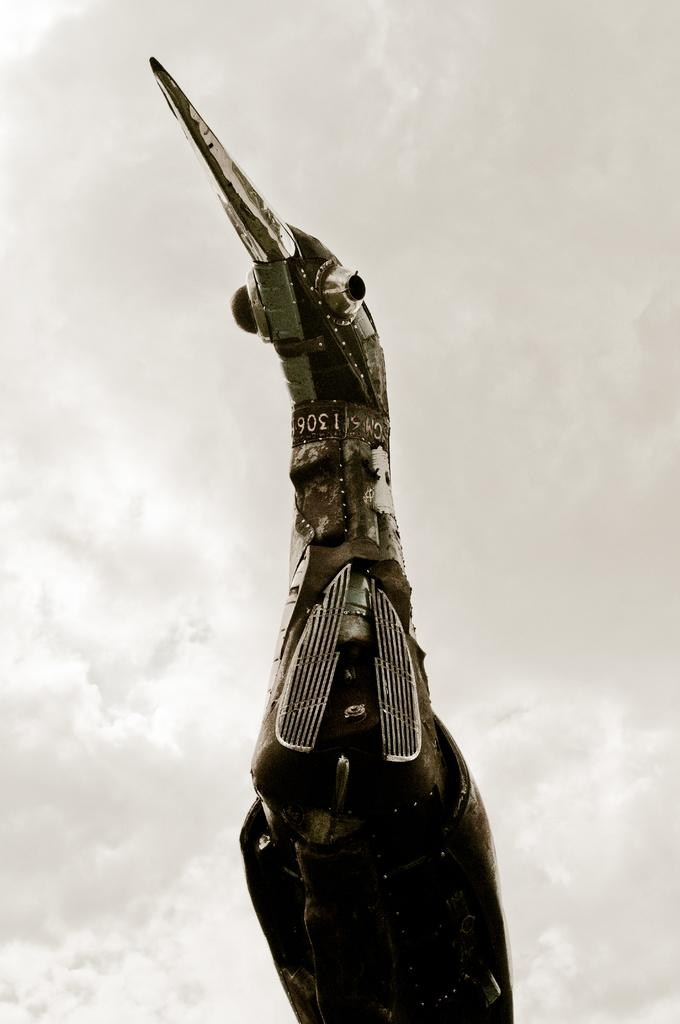What is the main subject in the center of the image? There is a bird architecture in the center of the image. Are there any words or letters on the bird architecture? Yes, there is some text on the bird architecture. What can be seen in the background of the image? The sky is visible in the background of the image, and clouds are present. What type of polish is being applied to the bird architecture in the image? There is no indication in the image that any polish is being applied to the bird architecture. 